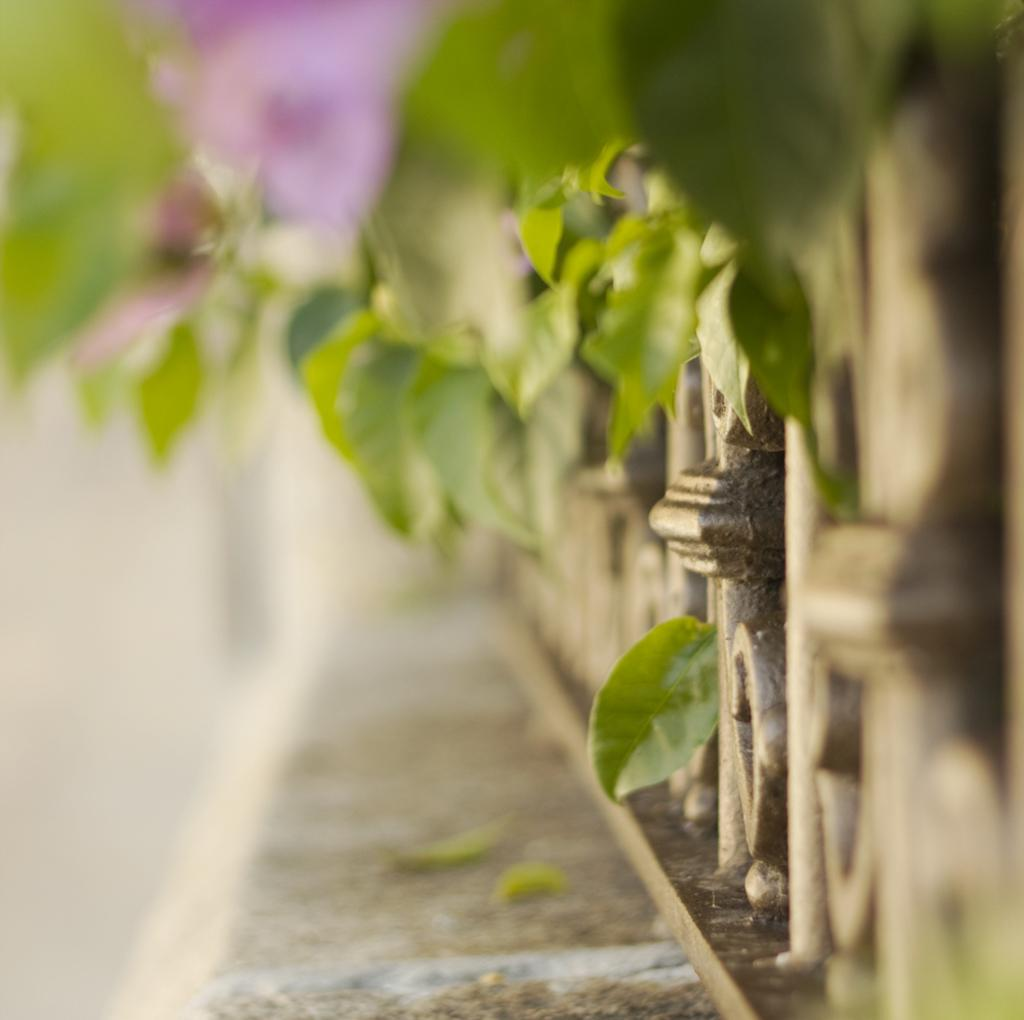What is located in the center of the image? There is a fence, a tree, and a wall in the center of the image. Can you describe the fence in the image? The fence is in the center of the image. What else is present in the center of the image besides the fence? There is also a tree and a wall in the center of the image. What type of toy can be seen hanging from the tree in the image? There is no toy present in the image; it features a fence, a tree, and a wall. What color is the frog sitting on the wall in the image? There is no frog present in the image; it only features a fence, a tree, and a wall. 